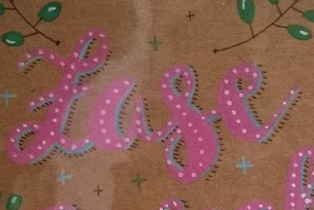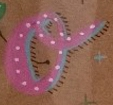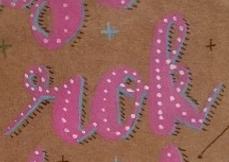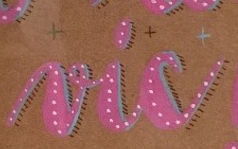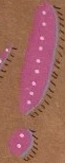What text is displayed in these images sequentially, separated by a semicolon? Lase; o; rok; vic; ! 